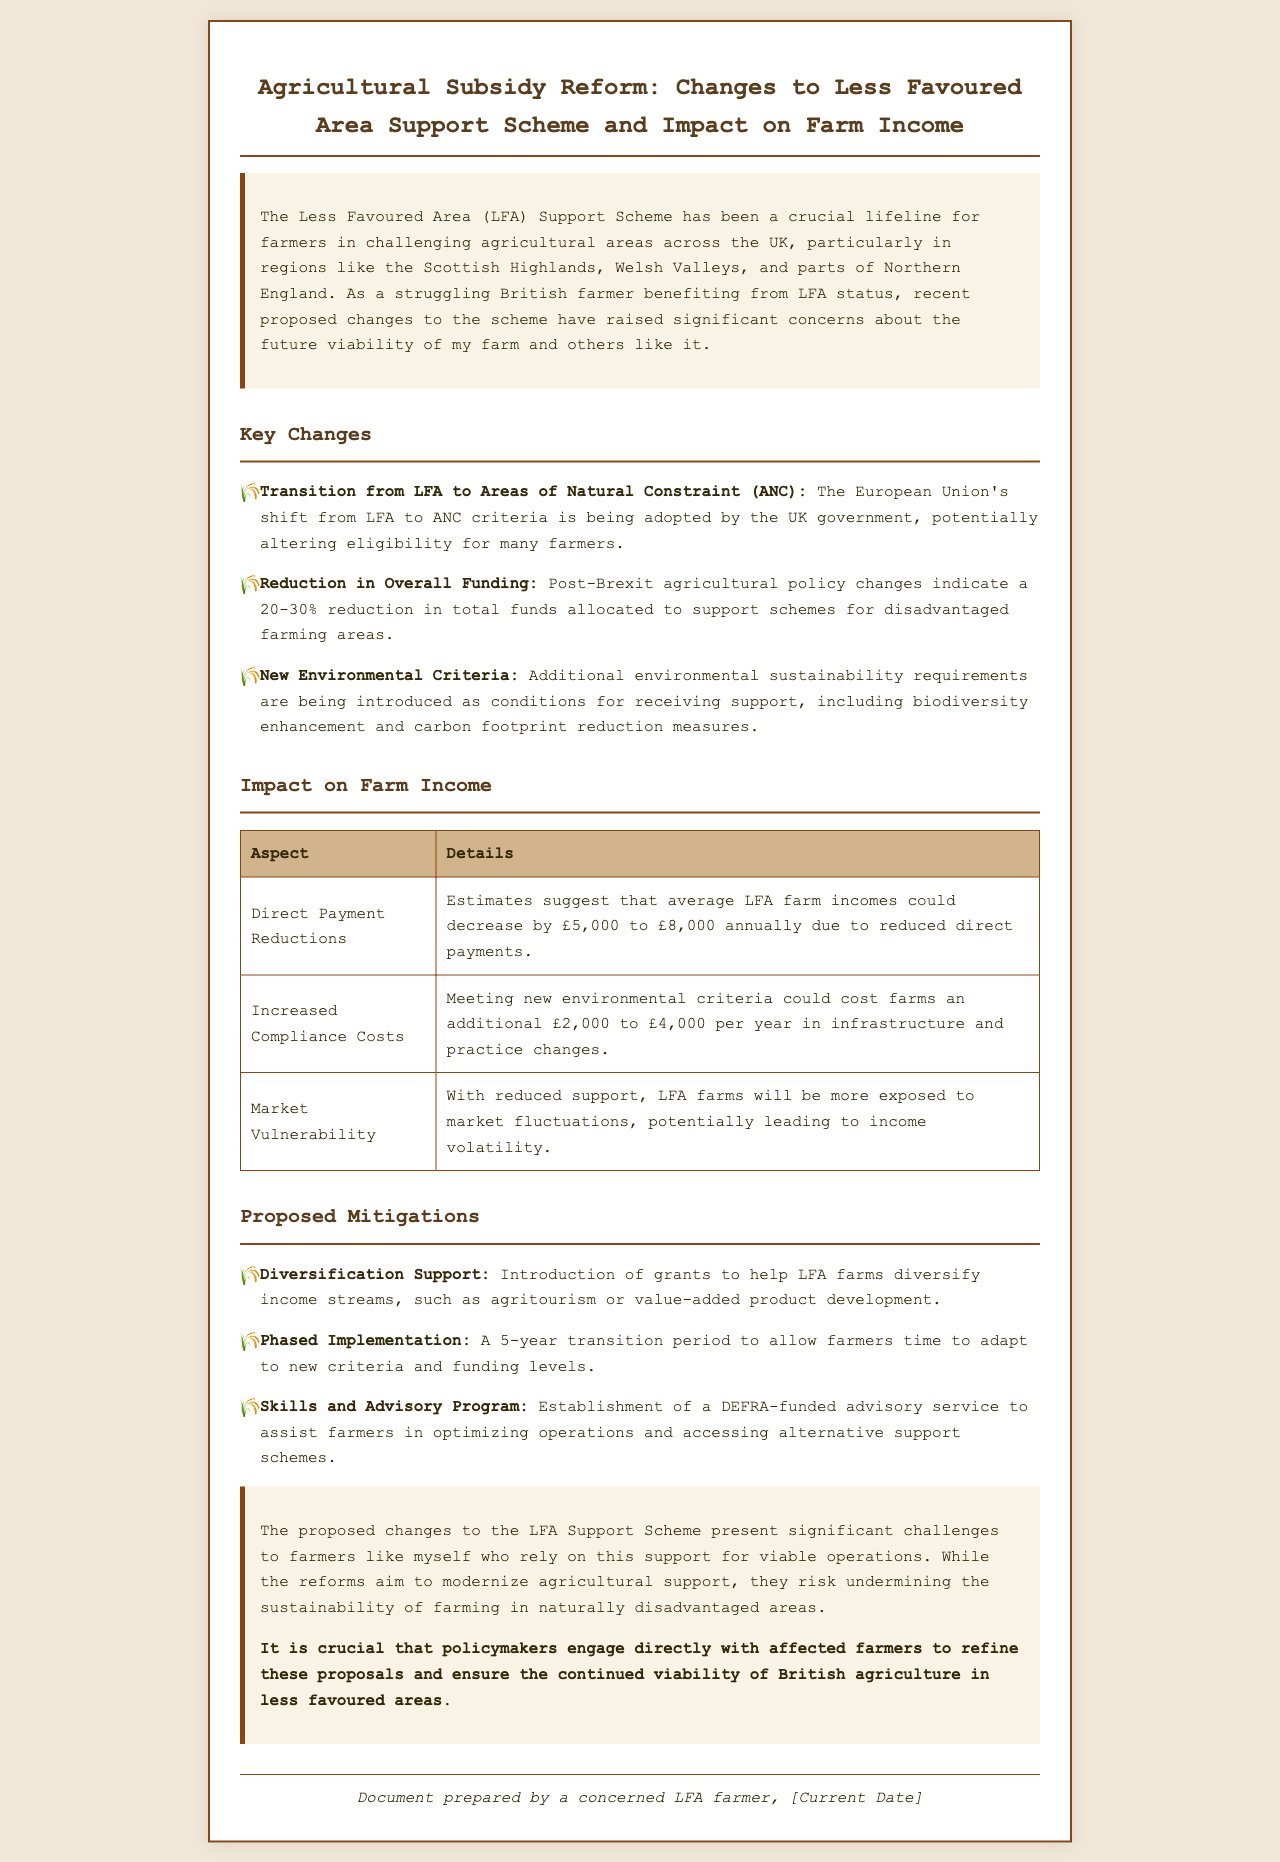What is the new term the EU is using instead of LFA? The document states that the EU's shift from LFA to ANC criteria is being adopted by the UK government.
Answer: ANC What is the estimated reduction in total funds for support schemes? The document indicates a 20-30% reduction in total funds allocated to support schemes for disadvantaged farming areas.
Answer: 20-30% What additional costs might farmers face due to new environmental criteria? The meeting of new environmental criteria could cost farms an additional £2,000 to £4,000 per year in infrastructure and practice changes.
Answer: £2,000 to £4,000 What is the potential decrease in average LFA farm incomes annually? The document estimates that average LFA farm incomes could decrease by £5,000 to £8,000 annually due to reduced direct payments.
Answer: £5,000 to £8,000 What kind of support is proposed for diversification? The document mentions the introduction of grants to help LFA farms diversify income streams.
Answer: Grants What is the duration of the proposed transition period? The proposed transition period is stated to be 5 years to allow farmers time to adapt to new criteria and funding levels.
Answer: 5 years Who is responsible for the proposed advisory service? The establishment of a DEFRA-funded advisory service is mentioned in the document.
Answer: DEFRA What do farmers need to do to access alternative support schemes? The document states that the advisory service will assist farmers in optimizing operations and accessing alternative support schemes.
Answer: Optimize operations 